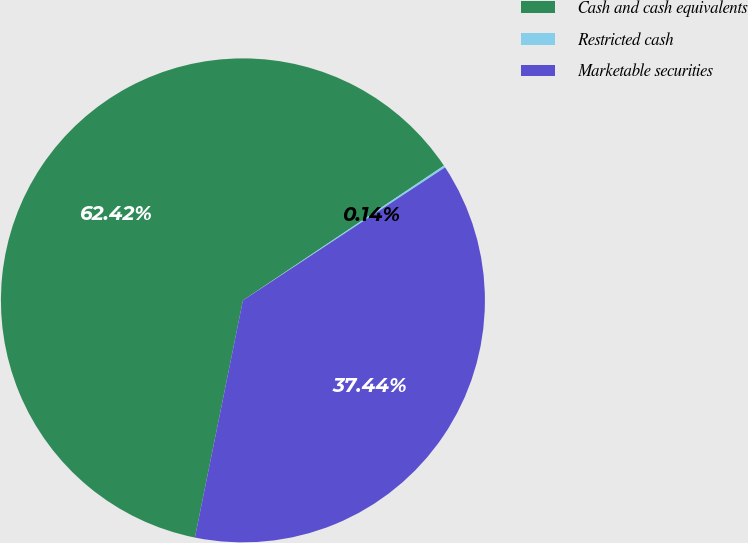Convert chart. <chart><loc_0><loc_0><loc_500><loc_500><pie_chart><fcel>Cash and cash equivalents<fcel>Restricted cash<fcel>Marketable securities<nl><fcel>62.42%<fcel>0.14%<fcel>37.44%<nl></chart> 